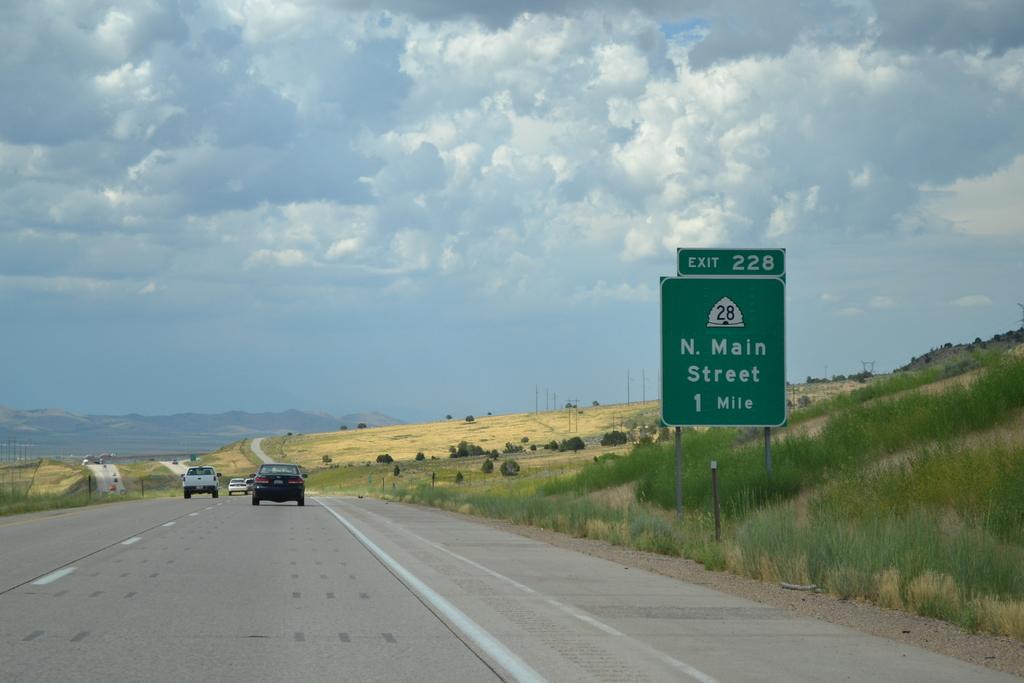How far is the n. main street exit?
Provide a succinct answer. 1 mile. What exit is this?
Give a very brief answer. 228. 